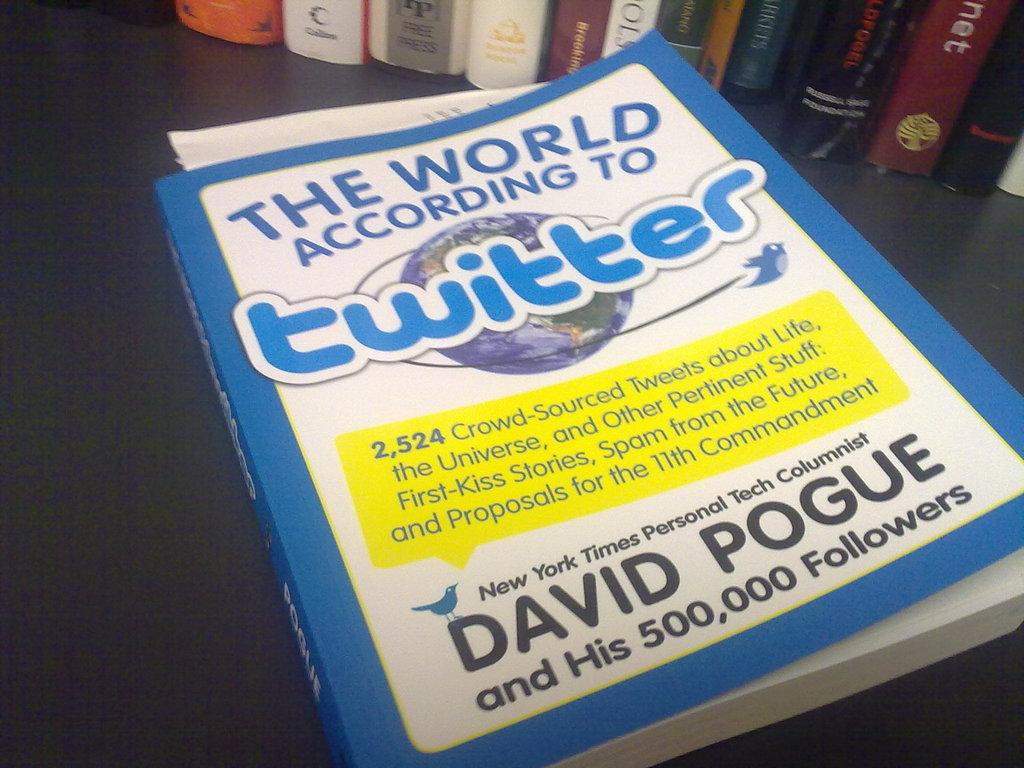<image>
Summarize the visual content of the image. A book on a table titled The World According to Twitter by David Pogue 